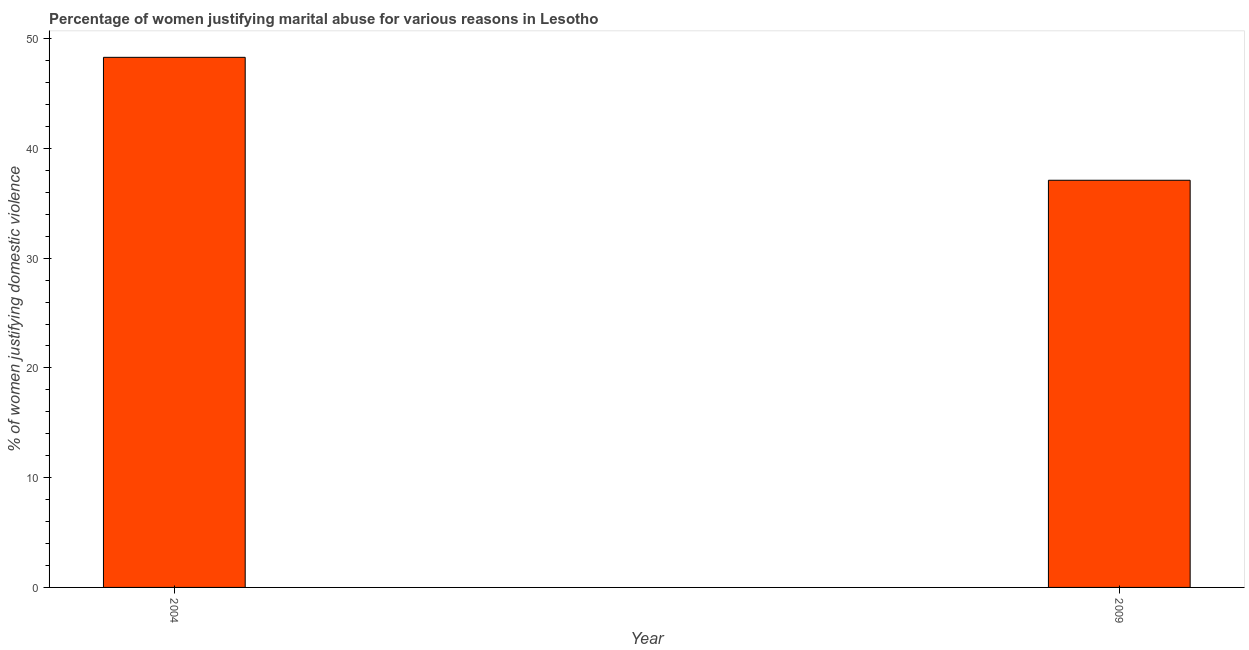What is the title of the graph?
Your answer should be compact. Percentage of women justifying marital abuse for various reasons in Lesotho. What is the label or title of the X-axis?
Provide a short and direct response. Year. What is the label or title of the Y-axis?
Give a very brief answer. % of women justifying domestic violence. What is the percentage of women justifying marital abuse in 2004?
Your answer should be very brief. 48.3. Across all years, what is the maximum percentage of women justifying marital abuse?
Your answer should be very brief. 48.3. Across all years, what is the minimum percentage of women justifying marital abuse?
Provide a succinct answer. 37.1. In which year was the percentage of women justifying marital abuse maximum?
Offer a terse response. 2004. What is the sum of the percentage of women justifying marital abuse?
Give a very brief answer. 85.4. What is the difference between the percentage of women justifying marital abuse in 2004 and 2009?
Ensure brevity in your answer.  11.2. What is the average percentage of women justifying marital abuse per year?
Keep it short and to the point. 42.7. What is the median percentage of women justifying marital abuse?
Provide a succinct answer. 42.7. What is the ratio of the percentage of women justifying marital abuse in 2004 to that in 2009?
Provide a succinct answer. 1.3. How many years are there in the graph?
Give a very brief answer. 2. What is the % of women justifying domestic violence in 2004?
Your answer should be compact. 48.3. What is the % of women justifying domestic violence in 2009?
Your response must be concise. 37.1. What is the difference between the % of women justifying domestic violence in 2004 and 2009?
Your response must be concise. 11.2. What is the ratio of the % of women justifying domestic violence in 2004 to that in 2009?
Ensure brevity in your answer.  1.3. 